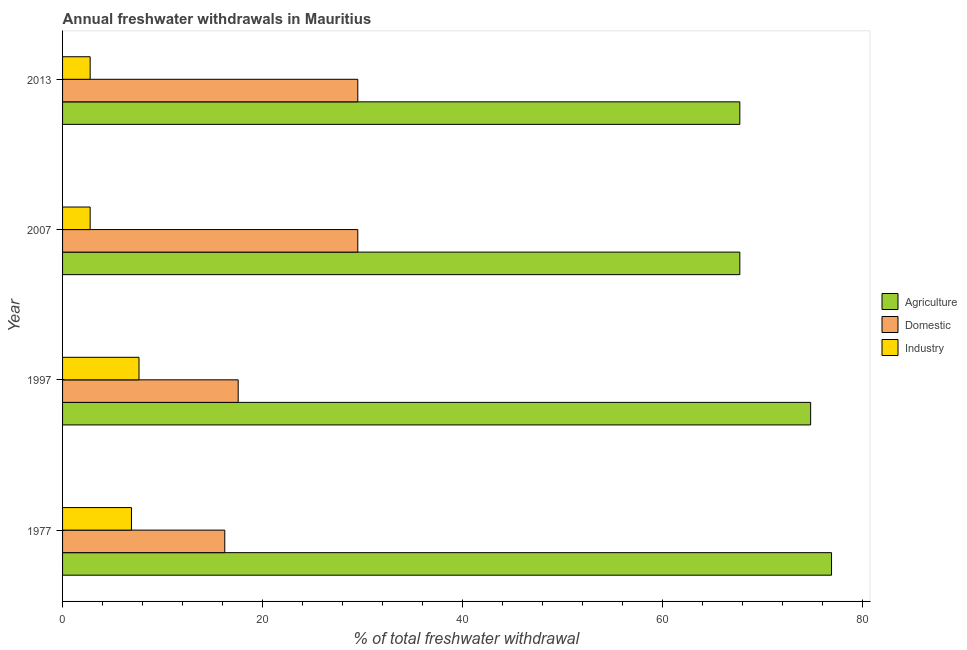How many groups of bars are there?
Make the answer very short. 4. How many bars are there on the 1st tick from the top?
Your answer should be compact. 3. How many bars are there on the 1st tick from the bottom?
Give a very brief answer. 3. What is the label of the 2nd group of bars from the top?
Offer a very short reply. 2007. In how many cases, is the number of bars for a given year not equal to the number of legend labels?
Make the answer very short. 0. What is the percentage of freshwater withdrawal for industry in 1977?
Provide a short and direct response. 6.89. Across all years, what is the maximum percentage of freshwater withdrawal for agriculture?
Make the answer very short. 76.89. Across all years, what is the minimum percentage of freshwater withdrawal for industry?
Give a very brief answer. 2.76. What is the total percentage of freshwater withdrawal for industry in the graph?
Offer a terse response. 20.05. What is the difference between the percentage of freshwater withdrawal for domestic purposes in 1997 and that in 2013?
Your answer should be compact. -11.96. What is the difference between the percentage of freshwater withdrawal for domestic purposes in 2013 and the percentage of freshwater withdrawal for agriculture in 1997?
Provide a succinct answer. -45.28. What is the average percentage of freshwater withdrawal for industry per year?
Provide a succinct answer. 5.01. In the year 2007, what is the difference between the percentage of freshwater withdrawal for agriculture and percentage of freshwater withdrawal for industry?
Keep it short and to the point. 64.96. In how many years, is the percentage of freshwater withdrawal for agriculture greater than 40 %?
Provide a succinct answer. 4. What is the ratio of the percentage of freshwater withdrawal for industry in 1997 to that in 2013?
Your response must be concise. 2.77. Is the difference between the percentage of freshwater withdrawal for domestic purposes in 1997 and 2013 greater than the difference between the percentage of freshwater withdrawal for industry in 1997 and 2013?
Ensure brevity in your answer.  No. What is the difference between the highest and the second highest percentage of freshwater withdrawal for industry?
Ensure brevity in your answer.  0.75. What is the difference between the highest and the lowest percentage of freshwater withdrawal for agriculture?
Give a very brief answer. 9.17. In how many years, is the percentage of freshwater withdrawal for industry greater than the average percentage of freshwater withdrawal for industry taken over all years?
Provide a short and direct response. 2. What does the 1st bar from the top in 1977 represents?
Make the answer very short. Industry. What does the 1st bar from the bottom in 2007 represents?
Keep it short and to the point. Agriculture. How many bars are there?
Offer a very short reply. 12. Are all the bars in the graph horizontal?
Your response must be concise. Yes. How many years are there in the graph?
Your response must be concise. 4. Does the graph contain any zero values?
Your response must be concise. No. Does the graph contain grids?
Your answer should be very brief. No. Where does the legend appear in the graph?
Give a very brief answer. Center right. How are the legend labels stacked?
Give a very brief answer. Vertical. What is the title of the graph?
Make the answer very short. Annual freshwater withdrawals in Mauritius. What is the label or title of the X-axis?
Your answer should be compact. % of total freshwater withdrawal. What is the label or title of the Y-axis?
Your answer should be very brief. Year. What is the % of total freshwater withdrawal of Agriculture in 1977?
Keep it short and to the point. 76.89. What is the % of total freshwater withdrawal of Domestic in 1977?
Offer a very short reply. 16.22. What is the % of total freshwater withdrawal in Industry in 1977?
Make the answer very short. 6.89. What is the % of total freshwater withdrawal of Agriculture in 1997?
Offer a very short reply. 74.8. What is the % of total freshwater withdrawal of Domestic in 1997?
Provide a short and direct response. 17.56. What is the % of total freshwater withdrawal of Industry in 1997?
Offer a terse response. 7.64. What is the % of total freshwater withdrawal of Agriculture in 2007?
Your answer should be very brief. 67.72. What is the % of total freshwater withdrawal of Domestic in 2007?
Provide a succinct answer. 29.52. What is the % of total freshwater withdrawal in Industry in 2007?
Keep it short and to the point. 2.76. What is the % of total freshwater withdrawal of Agriculture in 2013?
Your answer should be very brief. 67.72. What is the % of total freshwater withdrawal in Domestic in 2013?
Make the answer very short. 29.52. What is the % of total freshwater withdrawal in Industry in 2013?
Give a very brief answer. 2.76. Across all years, what is the maximum % of total freshwater withdrawal in Agriculture?
Your answer should be very brief. 76.89. Across all years, what is the maximum % of total freshwater withdrawal of Domestic?
Your answer should be very brief. 29.52. Across all years, what is the maximum % of total freshwater withdrawal in Industry?
Provide a succinct answer. 7.64. Across all years, what is the minimum % of total freshwater withdrawal in Agriculture?
Your response must be concise. 67.72. Across all years, what is the minimum % of total freshwater withdrawal of Domestic?
Provide a short and direct response. 16.22. Across all years, what is the minimum % of total freshwater withdrawal in Industry?
Give a very brief answer. 2.76. What is the total % of total freshwater withdrawal of Agriculture in the graph?
Ensure brevity in your answer.  287.13. What is the total % of total freshwater withdrawal of Domestic in the graph?
Provide a short and direct response. 92.82. What is the total % of total freshwater withdrawal in Industry in the graph?
Ensure brevity in your answer.  20.05. What is the difference between the % of total freshwater withdrawal of Agriculture in 1977 and that in 1997?
Make the answer very short. 2.09. What is the difference between the % of total freshwater withdrawal of Domestic in 1977 and that in 1997?
Ensure brevity in your answer.  -1.34. What is the difference between the % of total freshwater withdrawal of Industry in 1977 and that in 1997?
Provide a short and direct response. -0.75. What is the difference between the % of total freshwater withdrawal of Agriculture in 1977 and that in 2007?
Ensure brevity in your answer.  9.17. What is the difference between the % of total freshwater withdrawal of Domestic in 1977 and that in 2007?
Your answer should be very brief. -13.3. What is the difference between the % of total freshwater withdrawal in Industry in 1977 and that in 2007?
Provide a succinct answer. 4.13. What is the difference between the % of total freshwater withdrawal in Agriculture in 1977 and that in 2013?
Offer a terse response. 9.17. What is the difference between the % of total freshwater withdrawal of Domestic in 1977 and that in 2013?
Make the answer very short. -13.3. What is the difference between the % of total freshwater withdrawal in Industry in 1977 and that in 2013?
Provide a short and direct response. 4.13. What is the difference between the % of total freshwater withdrawal in Agriculture in 1997 and that in 2007?
Keep it short and to the point. 7.08. What is the difference between the % of total freshwater withdrawal of Domestic in 1997 and that in 2007?
Your answer should be compact. -11.96. What is the difference between the % of total freshwater withdrawal of Industry in 1997 and that in 2007?
Your answer should be compact. 4.88. What is the difference between the % of total freshwater withdrawal in Agriculture in 1997 and that in 2013?
Your answer should be compact. 7.08. What is the difference between the % of total freshwater withdrawal in Domestic in 1997 and that in 2013?
Provide a succinct answer. -11.96. What is the difference between the % of total freshwater withdrawal in Industry in 1997 and that in 2013?
Give a very brief answer. 4.88. What is the difference between the % of total freshwater withdrawal in Agriculture in 1977 and the % of total freshwater withdrawal in Domestic in 1997?
Offer a very short reply. 59.33. What is the difference between the % of total freshwater withdrawal in Agriculture in 1977 and the % of total freshwater withdrawal in Industry in 1997?
Provide a short and direct response. 69.25. What is the difference between the % of total freshwater withdrawal in Domestic in 1977 and the % of total freshwater withdrawal in Industry in 1997?
Your response must be concise. 8.58. What is the difference between the % of total freshwater withdrawal in Agriculture in 1977 and the % of total freshwater withdrawal in Domestic in 2007?
Keep it short and to the point. 47.37. What is the difference between the % of total freshwater withdrawal of Agriculture in 1977 and the % of total freshwater withdrawal of Industry in 2007?
Provide a succinct answer. 74.13. What is the difference between the % of total freshwater withdrawal in Domestic in 1977 and the % of total freshwater withdrawal in Industry in 2007?
Ensure brevity in your answer.  13.46. What is the difference between the % of total freshwater withdrawal of Agriculture in 1977 and the % of total freshwater withdrawal of Domestic in 2013?
Ensure brevity in your answer.  47.37. What is the difference between the % of total freshwater withdrawal in Agriculture in 1977 and the % of total freshwater withdrawal in Industry in 2013?
Give a very brief answer. 74.13. What is the difference between the % of total freshwater withdrawal of Domestic in 1977 and the % of total freshwater withdrawal of Industry in 2013?
Your answer should be very brief. 13.46. What is the difference between the % of total freshwater withdrawal of Agriculture in 1997 and the % of total freshwater withdrawal of Domestic in 2007?
Offer a terse response. 45.28. What is the difference between the % of total freshwater withdrawal in Agriculture in 1997 and the % of total freshwater withdrawal in Industry in 2007?
Your response must be concise. 72.04. What is the difference between the % of total freshwater withdrawal in Domestic in 1997 and the % of total freshwater withdrawal in Industry in 2007?
Offer a terse response. 14.8. What is the difference between the % of total freshwater withdrawal in Agriculture in 1997 and the % of total freshwater withdrawal in Domestic in 2013?
Your answer should be compact. 45.28. What is the difference between the % of total freshwater withdrawal of Agriculture in 1997 and the % of total freshwater withdrawal of Industry in 2013?
Make the answer very short. 72.04. What is the difference between the % of total freshwater withdrawal of Domestic in 1997 and the % of total freshwater withdrawal of Industry in 2013?
Give a very brief answer. 14.8. What is the difference between the % of total freshwater withdrawal in Agriculture in 2007 and the % of total freshwater withdrawal in Domestic in 2013?
Your answer should be compact. 38.2. What is the difference between the % of total freshwater withdrawal of Agriculture in 2007 and the % of total freshwater withdrawal of Industry in 2013?
Give a very brief answer. 64.96. What is the difference between the % of total freshwater withdrawal of Domestic in 2007 and the % of total freshwater withdrawal of Industry in 2013?
Provide a short and direct response. 26.76. What is the average % of total freshwater withdrawal of Agriculture per year?
Make the answer very short. 71.78. What is the average % of total freshwater withdrawal in Domestic per year?
Your response must be concise. 23.2. What is the average % of total freshwater withdrawal of Industry per year?
Your response must be concise. 5.01. In the year 1977, what is the difference between the % of total freshwater withdrawal in Agriculture and % of total freshwater withdrawal in Domestic?
Your answer should be very brief. 60.67. In the year 1977, what is the difference between the % of total freshwater withdrawal of Agriculture and % of total freshwater withdrawal of Industry?
Make the answer very short. 70. In the year 1977, what is the difference between the % of total freshwater withdrawal of Domestic and % of total freshwater withdrawal of Industry?
Your answer should be compact. 9.33. In the year 1997, what is the difference between the % of total freshwater withdrawal in Agriculture and % of total freshwater withdrawal in Domestic?
Offer a very short reply. 57.24. In the year 1997, what is the difference between the % of total freshwater withdrawal in Agriculture and % of total freshwater withdrawal in Industry?
Ensure brevity in your answer.  67.16. In the year 1997, what is the difference between the % of total freshwater withdrawal in Domestic and % of total freshwater withdrawal in Industry?
Ensure brevity in your answer.  9.92. In the year 2007, what is the difference between the % of total freshwater withdrawal of Agriculture and % of total freshwater withdrawal of Domestic?
Offer a very short reply. 38.2. In the year 2007, what is the difference between the % of total freshwater withdrawal in Agriculture and % of total freshwater withdrawal in Industry?
Your response must be concise. 64.96. In the year 2007, what is the difference between the % of total freshwater withdrawal of Domestic and % of total freshwater withdrawal of Industry?
Give a very brief answer. 26.76. In the year 2013, what is the difference between the % of total freshwater withdrawal of Agriculture and % of total freshwater withdrawal of Domestic?
Your answer should be very brief. 38.2. In the year 2013, what is the difference between the % of total freshwater withdrawal in Agriculture and % of total freshwater withdrawal in Industry?
Provide a short and direct response. 64.96. In the year 2013, what is the difference between the % of total freshwater withdrawal of Domestic and % of total freshwater withdrawal of Industry?
Make the answer very short. 26.76. What is the ratio of the % of total freshwater withdrawal in Agriculture in 1977 to that in 1997?
Your answer should be very brief. 1.03. What is the ratio of the % of total freshwater withdrawal in Domestic in 1977 to that in 1997?
Ensure brevity in your answer.  0.92. What is the ratio of the % of total freshwater withdrawal of Industry in 1977 to that in 1997?
Your answer should be compact. 0.9. What is the ratio of the % of total freshwater withdrawal in Agriculture in 1977 to that in 2007?
Your response must be concise. 1.14. What is the ratio of the % of total freshwater withdrawal in Domestic in 1977 to that in 2007?
Offer a very short reply. 0.55. What is the ratio of the % of total freshwater withdrawal of Industry in 1977 to that in 2007?
Provide a succinct answer. 2.5. What is the ratio of the % of total freshwater withdrawal in Agriculture in 1977 to that in 2013?
Offer a terse response. 1.14. What is the ratio of the % of total freshwater withdrawal of Domestic in 1977 to that in 2013?
Your answer should be compact. 0.55. What is the ratio of the % of total freshwater withdrawal of Industry in 1977 to that in 2013?
Provide a short and direct response. 2.5. What is the ratio of the % of total freshwater withdrawal in Agriculture in 1997 to that in 2007?
Provide a short and direct response. 1.1. What is the ratio of the % of total freshwater withdrawal in Domestic in 1997 to that in 2007?
Ensure brevity in your answer.  0.59. What is the ratio of the % of total freshwater withdrawal in Industry in 1997 to that in 2007?
Provide a succinct answer. 2.77. What is the ratio of the % of total freshwater withdrawal in Agriculture in 1997 to that in 2013?
Your answer should be very brief. 1.1. What is the ratio of the % of total freshwater withdrawal of Domestic in 1997 to that in 2013?
Keep it short and to the point. 0.59. What is the ratio of the % of total freshwater withdrawal of Industry in 1997 to that in 2013?
Provide a succinct answer. 2.77. What is the ratio of the % of total freshwater withdrawal of Domestic in 2007 to that in 2013?
Your answer should be very brief. 1. What is the ratio of the % of total freshwater withdrawal of Industry in 2007 to that in 2013?
Offer a very short reply. 1. What is the difference between the highest and the second highest % of total freshwater withdrawal of Agriculture?
Keep it short and to the point. 2.09. What is the difference between the highest and the second highest % of total freshwater withdrawal of Industry?
Make the answer very short. 0.75. What is the difference between the highest and the lowest % of total freshwater withdrawal of Agriculture?
Your answer should be very brief. 9.17. What is the difference between the highest and the lowest % of total freshwater withdrawal of Industry?
Provide a short and direct response. 4.88. 